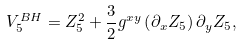<formula> <loc_0><loc_0><loc_500><loc_500>V _ { 5 } ^ { B H } = Z _ { 5 } ^ { 2 } + \frac { 3 } { 2 } g ^ { x y } \left ( \partial _ { x } Z _ { 5 } \right ) \partial _ { y } Z _ { 5 } ,</formula> 